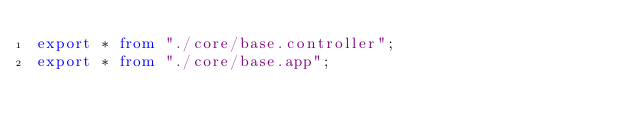Convert code to text. <code><loc_0><loc_0><loc_500><loc_500><_TypeScript_>export * from "./core/base.controller";
export * from "./core/base.app";
</code> 